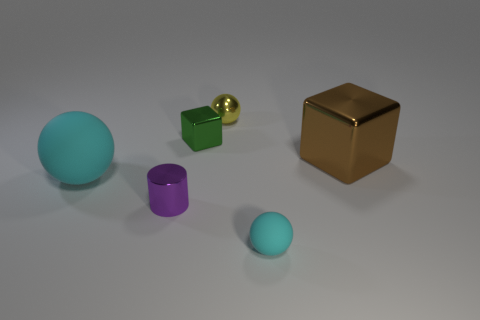Is there any other thing that has the same shape as the purple metal thing?
Make the answer very short. No. What size is the matte thing that is the same color as the large ball?
Offer a terse response. Small. There is a block that is to the right of the cyan matte object that is in front of the tiny purple shiny cylinder; how big is it?
Your answer should be compact. Large. Does the large object in front of the brown metallic block have the same shape as the tiny thing behind the small green metal thing?
Give a very brief answer. Yes. What shape is the cyan object that is to the left of the small object in front of the tiny purple cylinder?
Keep it short and to the point. Sphere. What is the size of the ball that is both right of the tiny purple shiny object and behind the small purple metallic object?
Ensure brevity in your answer.  Small. Do the large cyan object and the cyan thing to the right of the tiny green shiny block have the same shape?
Provide a succinct answer. Yes. The brown shiny object that is the same shape as the small green metallic object is what size?
Your answer should be very brief. Large. There is a large rubber ball; does it have the same color as the small ball in front of the tiny purple thing?
Your answer should be compact. Yes. What number of other objects are the same size as the brown thing?
Offer a very short reply. 1. 